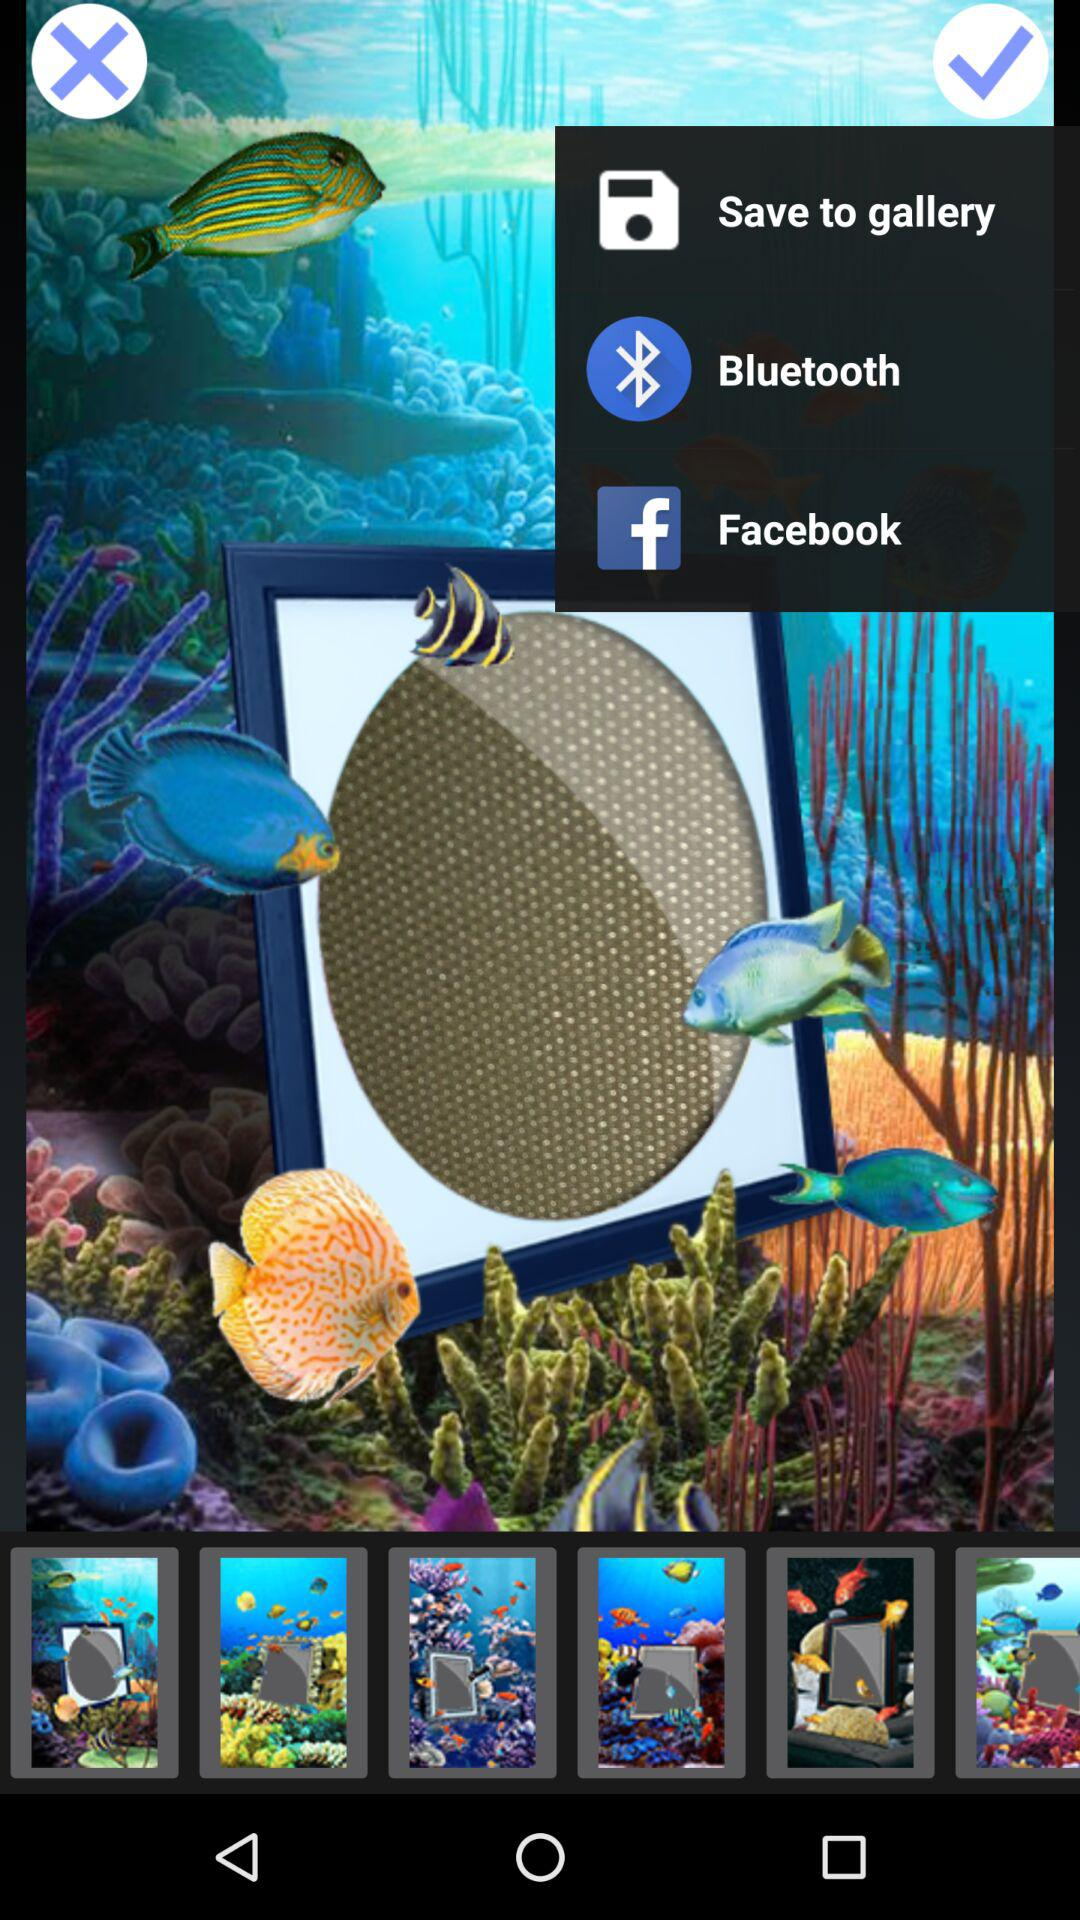Which applications can be used for sharing? The applications that can be used for sharing are "Bluetooth" and "Facebook". 